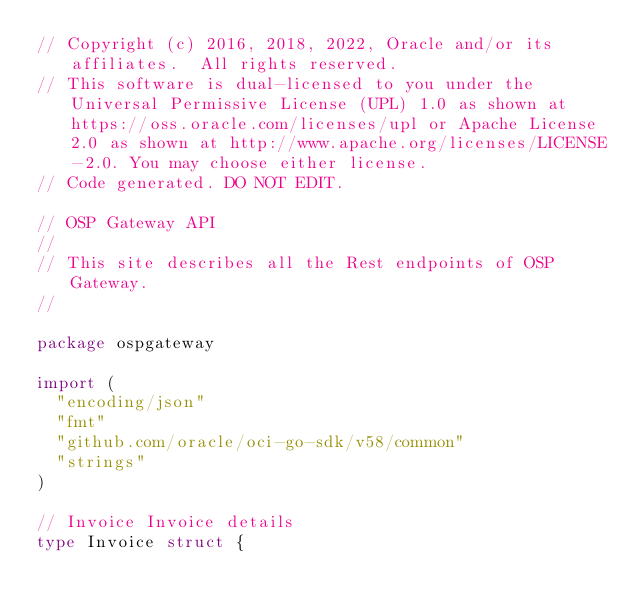<code> <loc_0><loc_0><loc_500><loc_500><_Go_>// Copyright (c) 2016, 2018, 2022, Oracle and/or its affiliates.  All rights reserved.
// This software is dual-licensed to you under the Universal Permissive License (UPL) 1.0 as shown at https://oss.oracle.com/licenses/upl or Apache License 2.0 as shown at http://www.apache.org/licenses/LICENSE-2.0. You may choose either license.
// Code generated. DO NOT EDIT.

// OSP Gateway API
//
// This site describes all the Rest endpoints of OSP Gateway.
//

package ospgateway

import (
	"encoding/json"
	"fmt"
	"github.com/oracle/oci-go-sdk/v58/common"
	"strings"
)

// Invoice Invoice details
type Invoice struct {
</code> 